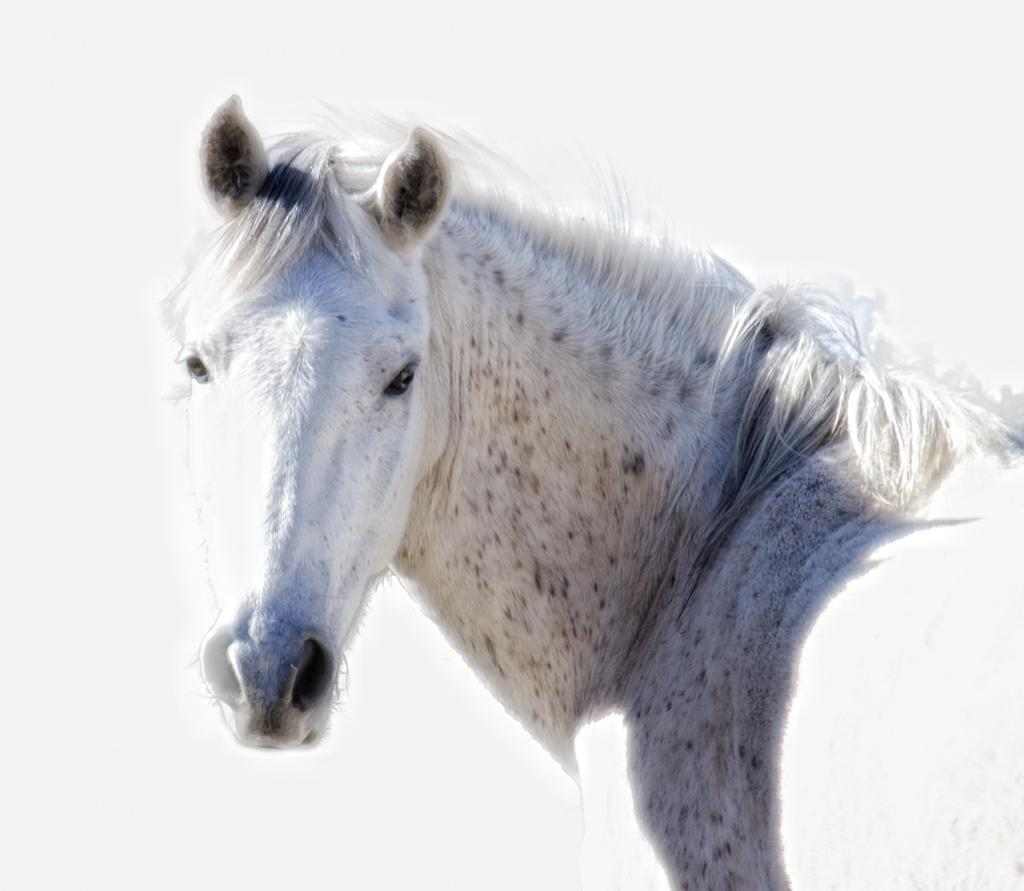What animal is the main subject of the image? There is a horse in the image. What color is the background of the image? The background of the image is white. Can you see any squirrels eating oatmeal in the image? There are no squirrels or oatmeal present in the image; it features a horse with a white background. 